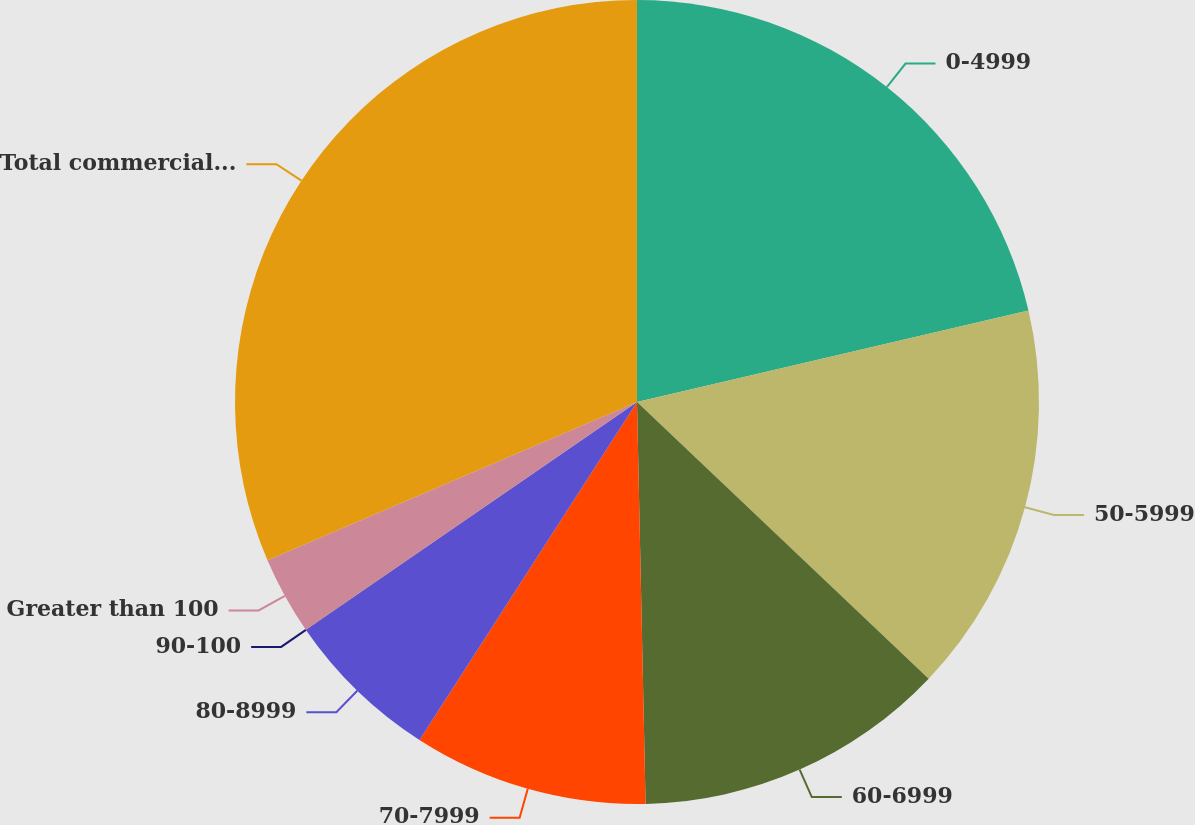<chart> <loc_0><loc_0><loc_500><loc_500><pie_chart><fcel>0-4999<fcel>50-5999<fcel>60-6999<fcel>70-7999<fcel>80-8999<fcel>90-100<fcel>Greater than 100<fcel>Total commercial and<nl><fcel>21.35%<fcel>15.73%<fcel>12.58%<fcel>9.44%<fcel>6.3%<fcel>0.01%<fcel>3.15%<fcel>31.44%<nl></chart> 